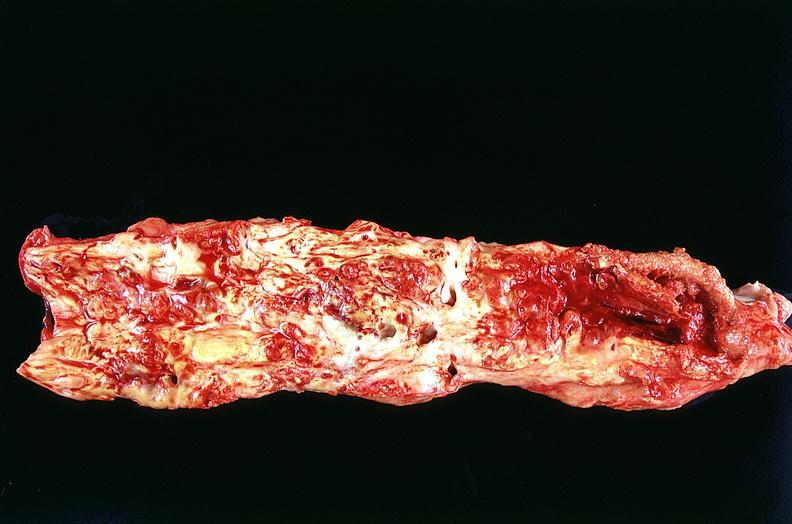s artery present?
Answer the question using a single word or phrase. No 